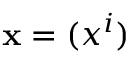<formula> <loc_0><loc_0><loc_500><loc_500>x = ( x ^ { i } )</formula> 